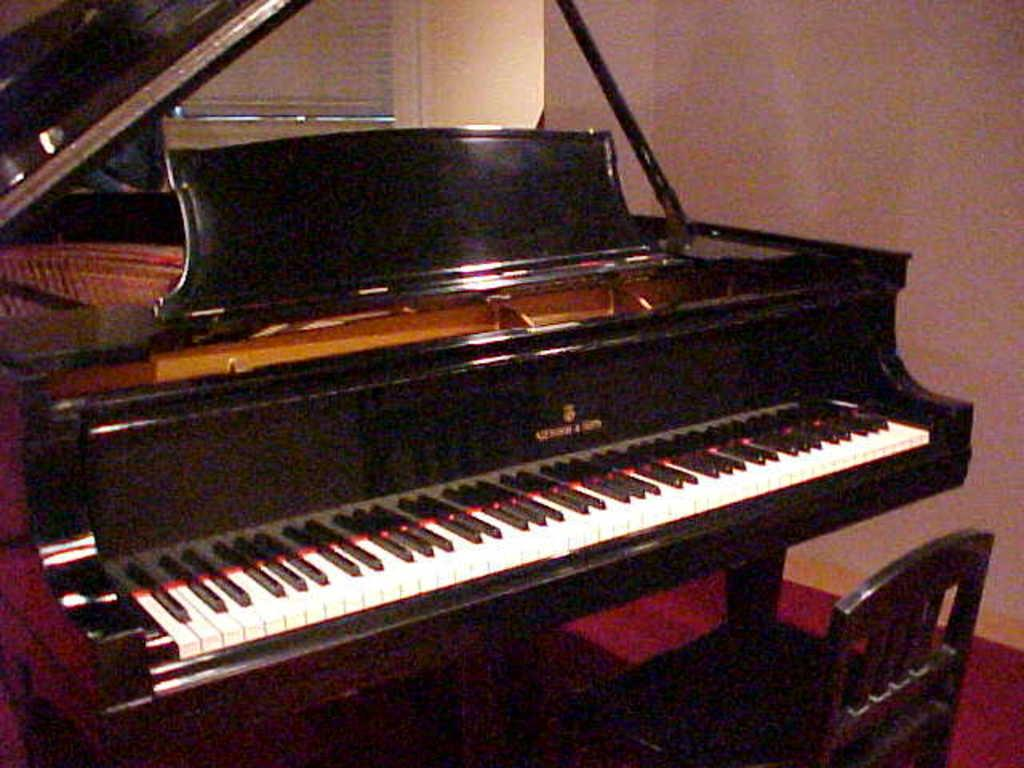What musical instrument is present in the image? There is a piano in the image. What can be seen above the piano in the image? There is a wall on the top of the image. Where is the chair located in the image? The chair is in the bottom right corner of the image. What type of sail is visible in the image? There is no sail present in the image; it features a piano, a wall, and a chair. 